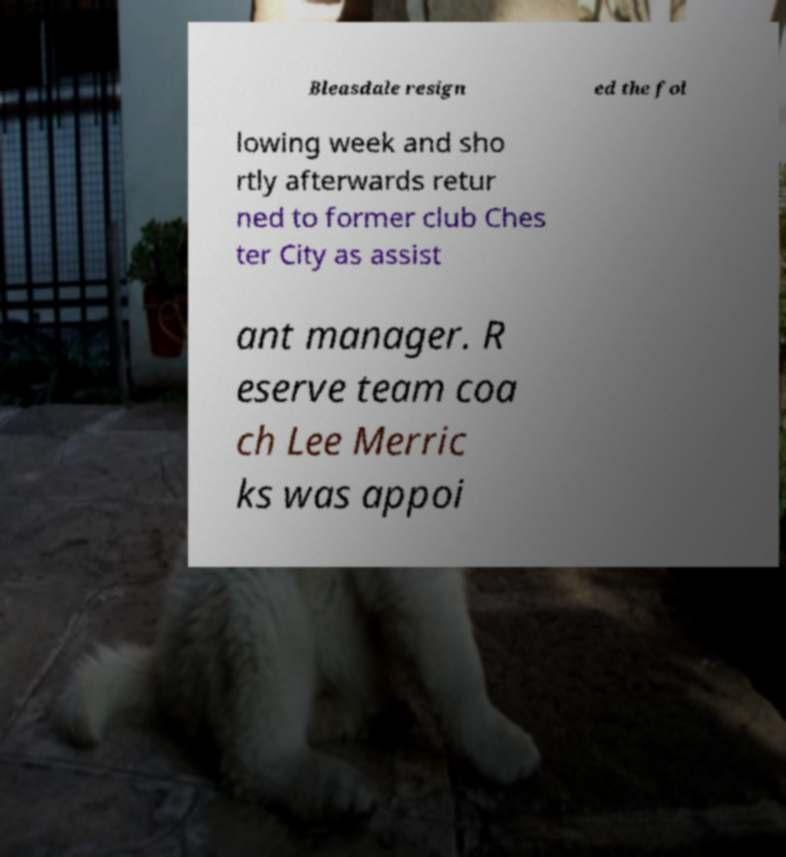Can you read and provide the text displayed in the image?This photo seems to have some interesting text. Can you extract and type it out for me? Bleasdale resign ed the fol lowing week and sho rtly afterwards retur ned to former club Ches ter City as assist ant manager. R eserve team coa ch Lee Merric ks was appoi 